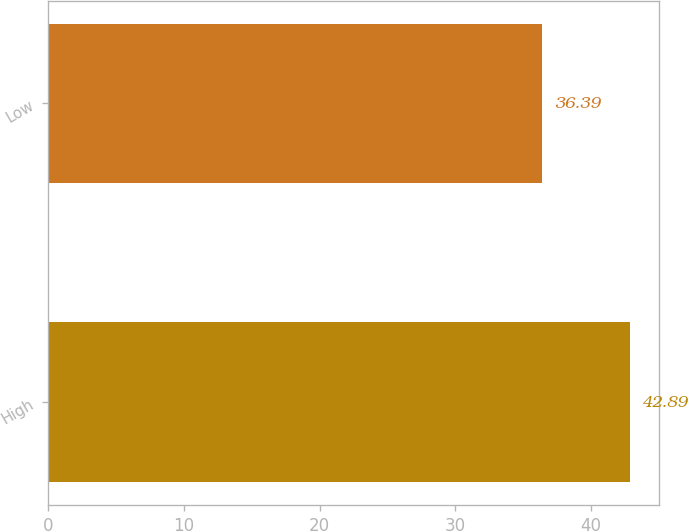<chart> <loc_0><loc_0><loc_500><loc_500><bar_chart><fcel>High<fcel>Low<nl><fcel>42.89<fcel>36.39<nl></chart> 